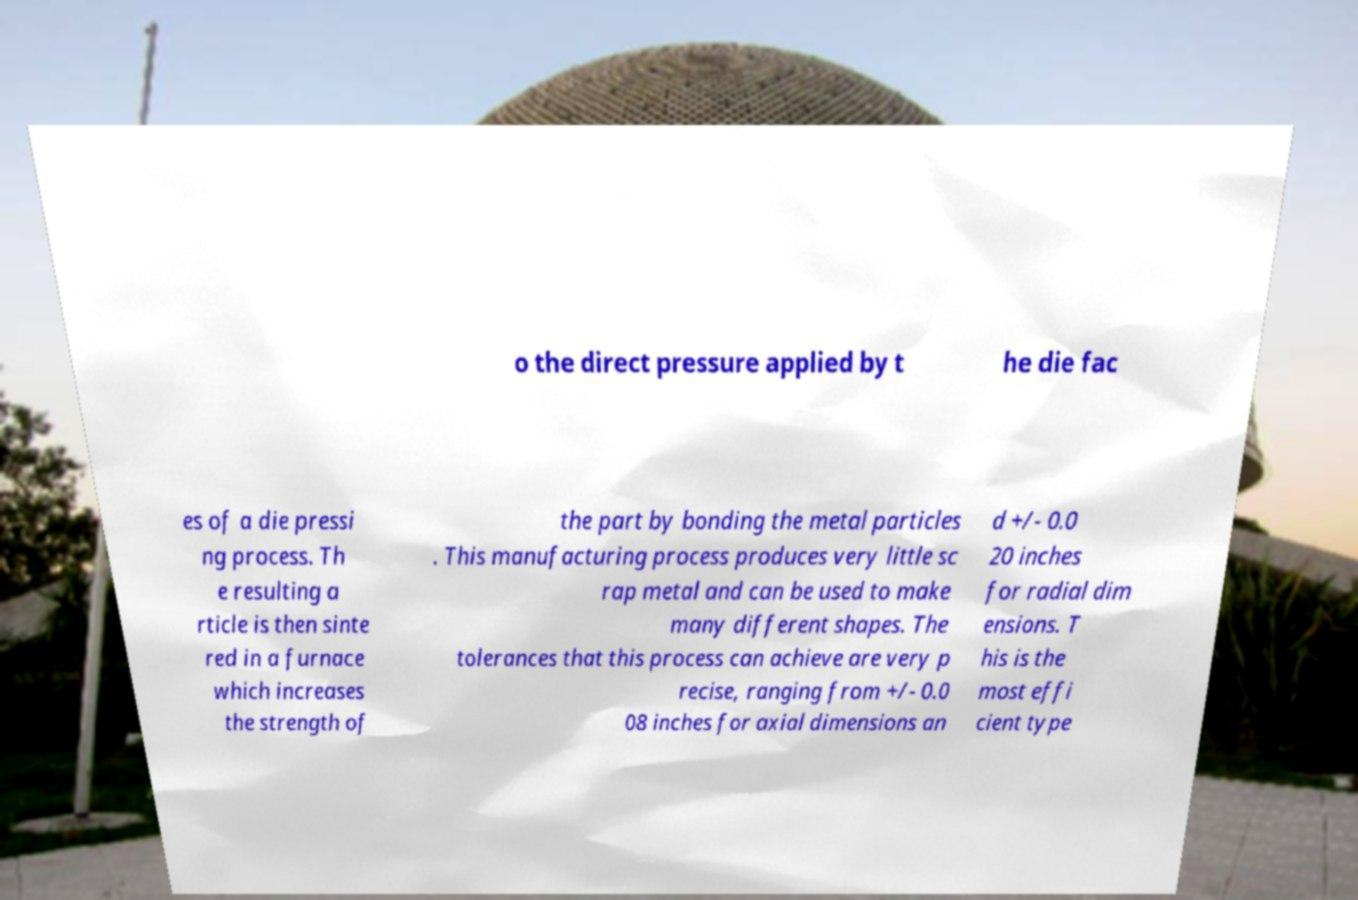Please identify and transcribe the text found in this image. o the direct pressure applied by t he die fac es of a die pressi ng process. Th e resulting a rticle is then sinte red in a furnace which increases the strength of the part by bonding the metal particles . This manufacturing process produces very little sc rap metal and can be used to make many different shapes. The tolerances that this process can achieve are very p recise, ranging from +/- 0.0 08 inches for axial dimensions an d +/- 0.0 20 inches for radial dim ensions. T his is the most effi cient type 